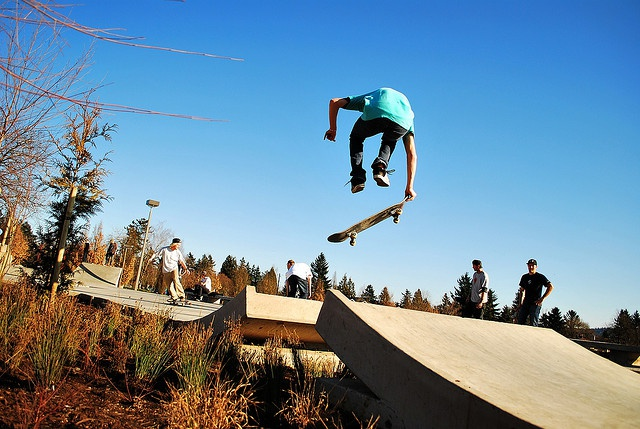Describe the objects in this image and their specific colors. I can see people in gray, black, cyan, and lightblue tones, people in gray, black, white, and lightblue tones, people in gray, ivory, maroon, khaki, and darkgray tones, skateboard in gray, black, olive, maroon, and tan tones, and people in gray, black, ivory, and maroon tones in this image. 